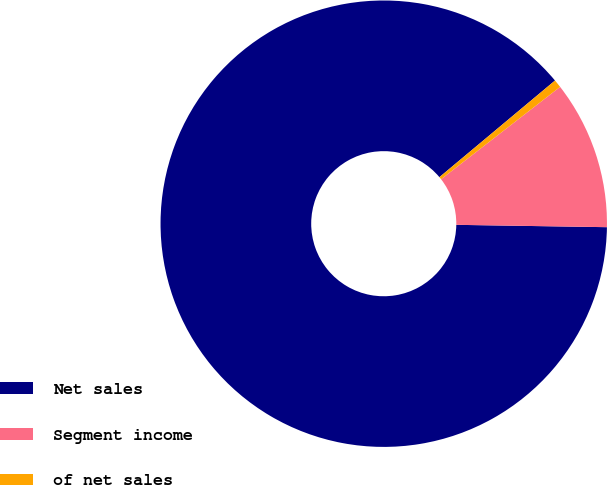Convert chart to OTSL. <chart><loc_0><loc_0><loc_500><loc_500><pie_chart><fcel>Net sales<fcel>Segment income<fcel>of net sales<nl><fcel>88.67%<fcel>10.75%<fcel>0.58%<nl></chart> 